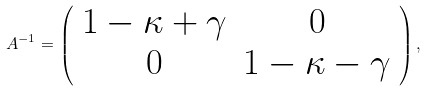Convert formula to latex. <formula><loc_0><loc_0><loc_500><loc_500>A ^ { - 1 } = \left ( \begin{array} { c c c } 1 - \kappa + \gamma & 0 \\ 0 & 1 - \kappa - \gamma \end{array} \right ) ,</formula> 